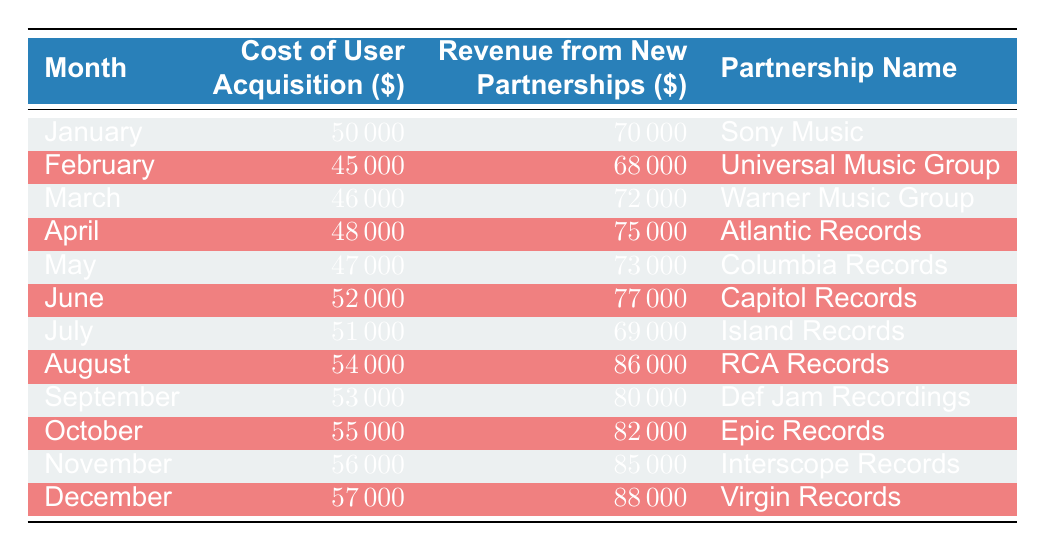What is the total revenue from new content partnerships for the entire year? To find the total revenue, we need to sum the revenue for each month listed in the table: 70000 + 68000 + 72000 + 75000 + 73000 + 77000 + 69000 + 86000 + 80000 + 82000 + 85000 + 88000 = 860000.
Answer: 860000 What is the cost of user acquisition for September? The cost of user acquisition for September is listed directly in the table as 53000.
Answer: 53000 Which partnership generated the highest revenue in a single month? Looking through the revenue figures month by month, we see that Virgin Records in December generated the highest revenue of 88000.
Answer: Virgin Records What is the average cost of user acquisition over the year? To find the average, we sum all the costs: 50000 + 45000 + 46000 + 48000 + 47000 + 52000 + 51000 + 54000 + 53000 + 55000 + 56000 + 57000 = 610000. There are 12 months, so we divide: 610000 / 12 = 50833.33.
Answer: 50833.33 Did the cost of user acquisition increase each month? By examining each month, we can see that the costs do not consistently increase. For example, February (45000) is less than January (50000), indicating that there is not a constant increase month to month.
Answer: No How much total revenue was generated from partnerships where the cost of user acquisition was greater than 51000? We first filter the months with acquisition costs greater than 51000: June (77000), August (86000), September (80000), October (82000), November (85000), December (88000). Adding these revenues gives us 77000 + 86000 + 80000 + 82000 + 85000 + 88000 = 418000.
Answer: 418000 What month had the lowest cost of user acquisition? By reviewing the table, we find that February has the lowest cost of user acquisition at 45000.
Answer: February Which partnership's revenue was less than its associated user acquisition cost? We look for partnerships where revenue is less than cost: January (70000 vs 50000), Universal (68000 vs 45000), etc. All partnerships show revenue greater than acquisition costs. Therefore, no partnership meets this criterion.
Answer: None 